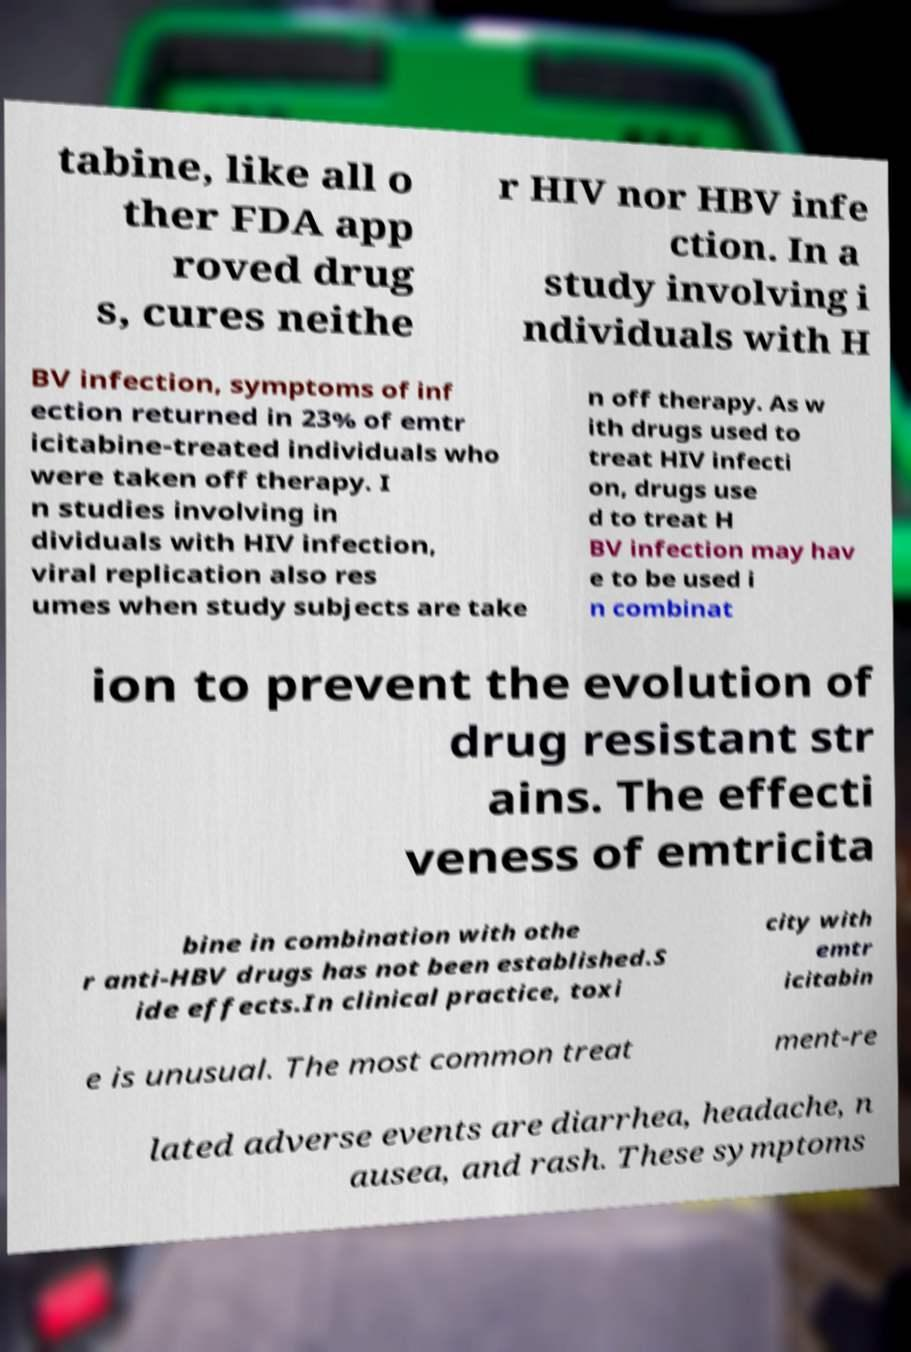Can you accurately transcribe the text from the provided image for me? tabine, like all o ther FDA app roved drug s, cures neithe r HIV nor HBV infe ction. In a study involving i ndividuals with H BV infection, symptoms of inf ection returned in 23% of emtr icitabine-treated individuals who were taken off therapy. I n studies involving in dividuals with HIV infection, viral replication also res umes when study subjects are take n off therapy. As w ith drugs used to treat HIV infecti on, drugs use d to treat H BV infection may hav e to be used i n combinat ion to prevent the evolution of drug resistant str ains. The effecti veness of emtricita bine in combination with othe r anti-HBV drugs has not been established.S ide effects.In clinical practice, toxi city with emtr icitabin e is unusual. The most common treat ment-re lated adverse events are diarrhea, headache, n ausea, and rash. These symptoms 